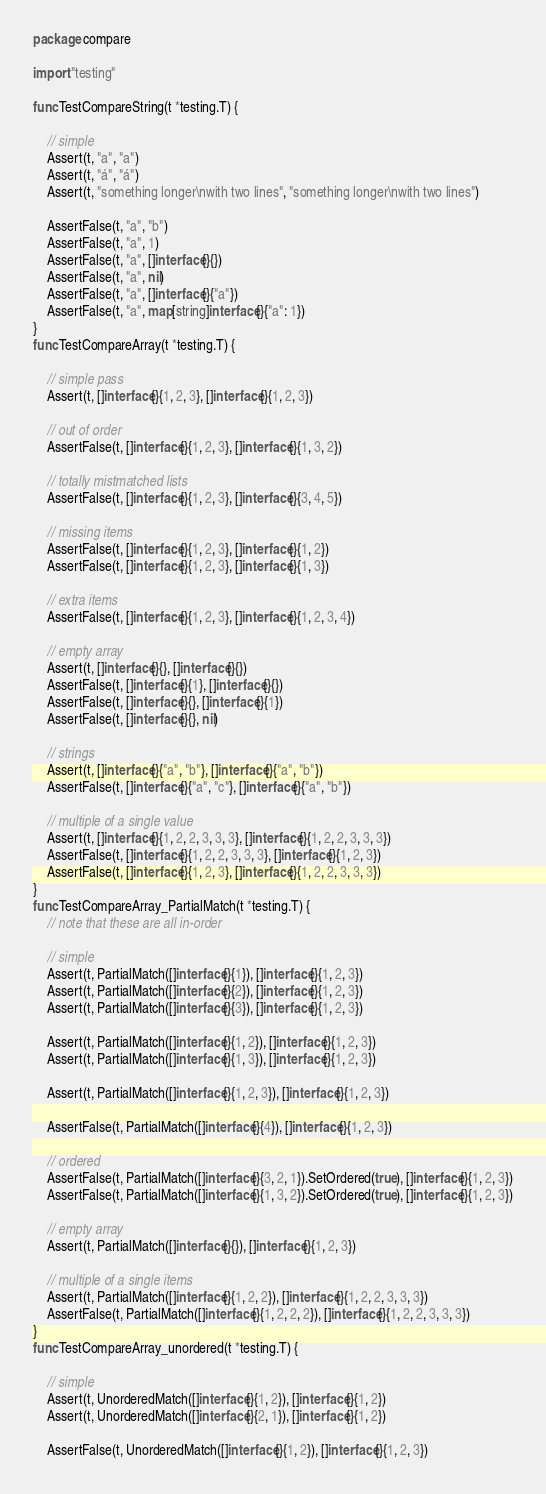<code> <loc_0><loc_0><loc_500><loc_500><_Go_>package compare

import "testing"

func TestCompareString(t *testing.T) {

	// simple
	Assert(t, "a", "a")
	Assert(t, "á", "á")
	Assert(t, "something longer\nwith two lines", "something longer\nwith two lines")

	AssertFalse(t, "a", "b")
	AssertFalse(t, "a", 1)
	AssertFalse(t, "a", []interface{}{})
	AssertFalse(t, "a", nil)
	AssertFalse(t, "a", []interface{}{"a"})
	AssertFalse(t, "a", map[string]interface{}{"a": 1})
}
func TestCompareArray(t *testing.T) {

	// simple pass
	Assert(t, []interface{}{1, 2, 3}, []interface{}{1, 2, 3})

	// out of order
	AssertFalse(t, []interface{}{1, 2, 3}, []interface{}{1, 3, 2})

	// totally mistmatched lists
	AssertFalse(t, []interface{}{1, 2, 3}, []interface{}{3, 4, 5})

	// missing items
	AssertFalse(t, []interface{}{1, 2, 3}, []interface{}{1, 2})
	AssertFalse(t, []interface{}{1, 2, 3}, []interface{}{1, 3})

	// extra items
	AssertFalse(t, []interface{}{1, 2, 3}, []interface{}{1, 2, 3, 4})

	// empty array
	Assert(t, []interface{}{}, []interface{}{})
	AssertFalse(t, []interface{}{1}, []interface{}{})
	AssertFalse(t, []interface{}{}, []interface{}{1})
	AssertFalse(t, []interface{}{}, nil)

	// strings
	Assert(t, []interface{}{"a", "b"}, []interface{}{"a", "b"})
	AssertFalse(t, []interface{}{"a", "c"}, []interface{}{"a", "b"})

	// multiple of a single value
	Assert(t, []interface{}{1, 2, 2, 3, 3, 3}, []interface{}{1, 2, 2, 3, 3, 3})
	AssertFalse(t, []interface{}{1, 2, 2, 3, 3, 3}, []interface{}{1, 2, 3})
	AssertFalse(t, []interface{}{1, 2, 3}, []interface{}{1, 2, 2, 3, 3, 3})
}
func TestCompareArray_PartialMatch(t *testing.T) {
	// note that these are all in-order

	// simple
	Assert(t, PartialMatch([]interface{}{1}), []interface{}{1, 2, 3})
	Assert(t, PartialMatch([]interface{}{2}), []interface{}{1, 2, 3})
	Assert(t, PartialMatch([]interface{}{3}), []interface{}{1, 2, 3})

	Assert(t, PartialMatch([]interface{}{1, 2}), []interface{}{1, 2, 3})
	Assert(t, PartialMatch([]interface{}{1, 3}), []interface{}{1, 2, 3})

	Assert(t, PartialMatch([]interface{}{1, 2, 3}), []interface{}{1, 2, 3})

	AssertFalse(t, PartialMatch([]interface{}{4}), []interface{}{1, 2, 3})

	// ordered
	AssertFalse(t, PartialMatch([]interface{}{3, 2, 1}).SetOrdered(true), []interface{}{1, 2, 3})
	AssertFalse(t, PartialMatch([]interface{}{1, 3, 2}).SetOrdered(true), []interface{}{1, 2, 3})

	// empty array
	Assert(t, PartialMatch([]interface{}{}), []interface{}{1, 2, 3})

	// multiple of a single items
	Assert(t, PartialMatch([]interface{}{1, 2, 2}), []interface{}{1, 2, 2, 3, 3, 3})
	AssertFalse(t, PartialMatch([]interface{}{1, 2, 2, 2}), []interface{}{1, 2, 2, 3, 3, 3})
}
func TestCompareArray_unordered(t *testing.T) {

	// simple
	Assert(t, UnorderedMatch([]interface{}{1, 2}), []interface{}{1, 2})
	Assert(t, UnorderedMatch([]interface{}{2, 1}), []interface{}{1, 2})

	AssertFalse(t, UnorderedMatch([]interface{}{1, 2}), []interface{}{1, 2, 3})</code> 